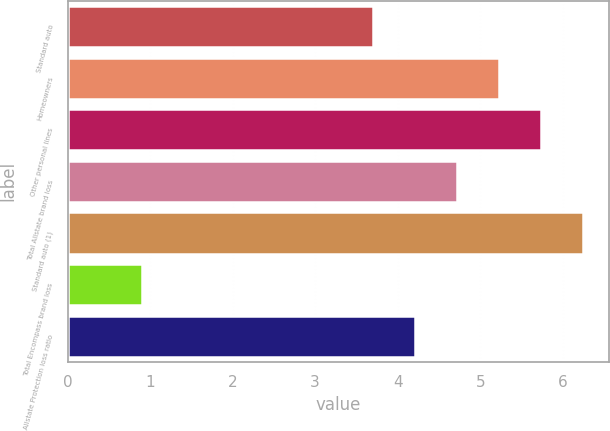Convert chart. <chart><loc_0><loc_0><loc_500><loc_500><bar_chart><fcel>Standard auto<fcel>Homeowners<fcel>Other personal lines<fcel>Total Allstate brand loss<fcel>Standard auto (1)<fcel>Total Encompass brand loss<fcel>Allstate Protection loss ratio<nl><fcel>3.7<fcel>5.23<fcel>5.74<fcel>4.72<fcel>6.25<fcel>0.9<fcel>4.21<nl></chart> 